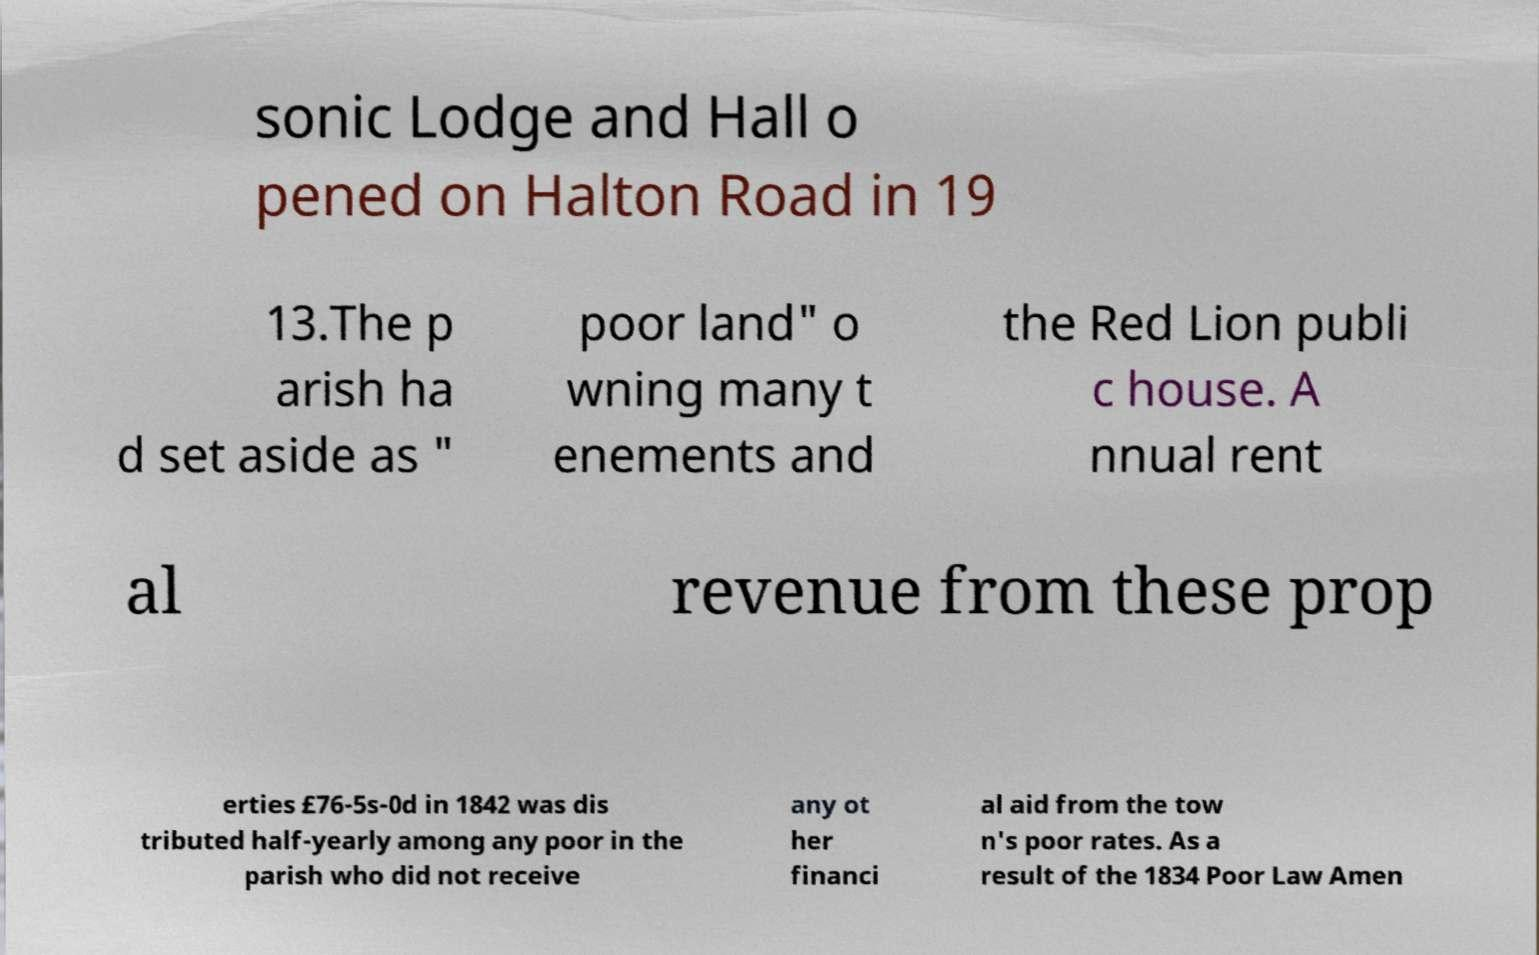Can you accurately transcribe the text from the provided image for me? sonic Lodge and Hall o pened on Halton Road in 19 13.The p arish ha d set aside as " poor land" o wning many t enements and the Red Lion publi c house. A nnual rent al revenue from these prop erties £76-5s-0d in 1842 was dis tributed half-yearly among any poor in the parish who did not receive any ot her financi al aid from the tow n's poor rates. As a result of the 1834 Poor Law Amen 